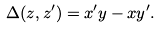<formula> <loc_0><loc_0><loc_500><loc_500>\Delta ( z , z ^ { \prime } ) = x ^ { \prime } y - x y ^ { \prime } .</formula> 